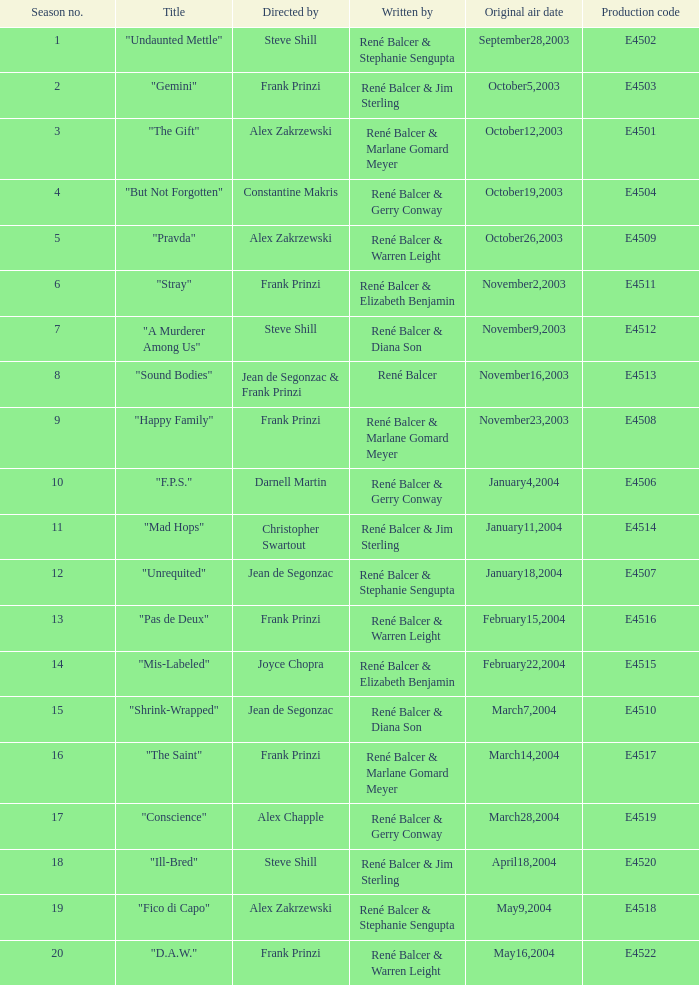What date did "d.a.w." Originally air? May16,2004. 